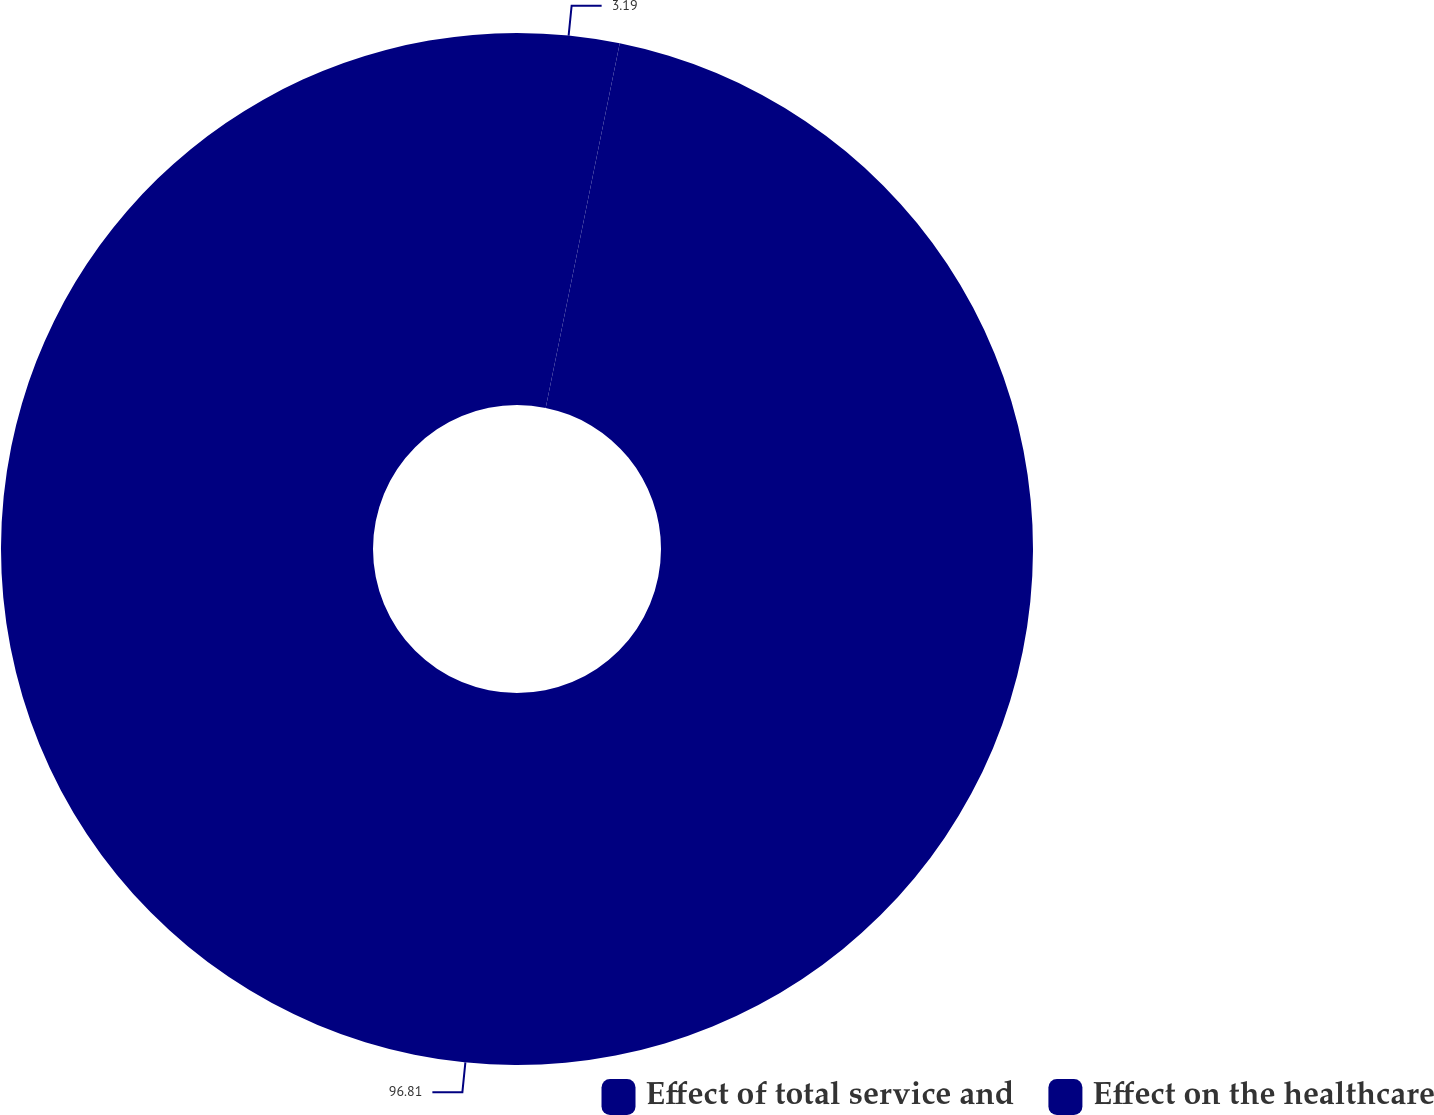Convert chart. <chart><loc_0><loc_0><loc_500><loc_500><pie_chart><fcel>Effect of total service and<fcel>Effect on the healthcare<nl><fcel>3.19%<fcel>96.81%<nl></chart> 